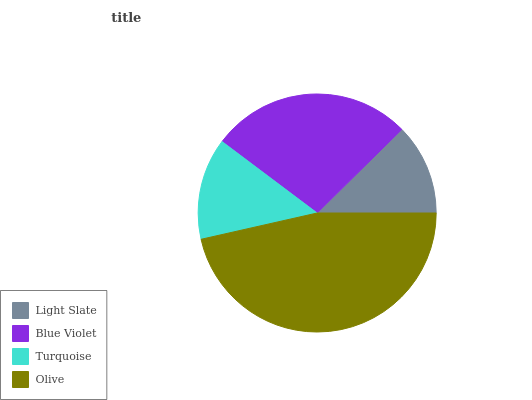Is Light Slate the minimum?
Answer yes or no. Yes. Is Olive the maximum?
Answer yes or no. Yes. Is Blue Violet the minimum?
Answer yes or no. No. Is Blue Violet the maximum?
Answer yes or no. No. Is Blue Violet greater than Light Slate?
Answer yes or no. Yes. Is Light Slate less than Blue Violet?
Answer yes or no. Yes. Is Light Slate greater than Blue Violet?
Answer yes or no. No. Is Blue Violet less than Light Slate?
Answer yes or no. No. Is Blue Violet the high median?
Answer yes or no. Yes. Is Turquoise the low median?
Answer yes or no. Yes. Is Turquoise the high median?
Answer yes or no. No. Is Blue Violet the low median?
Answer yes or no. No. 